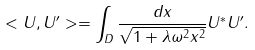Convert formula to latex. <formula><loc_0><loc_0><loc_500><loc_500>< U , U ^ { \prime } > = \int _ { D } \frac { d x } { \sqrt { 1 + \lambda \omega ^ { 2 } x ^ { 2 } } } U ^ { * } U ^ { \prime } .</formula> 